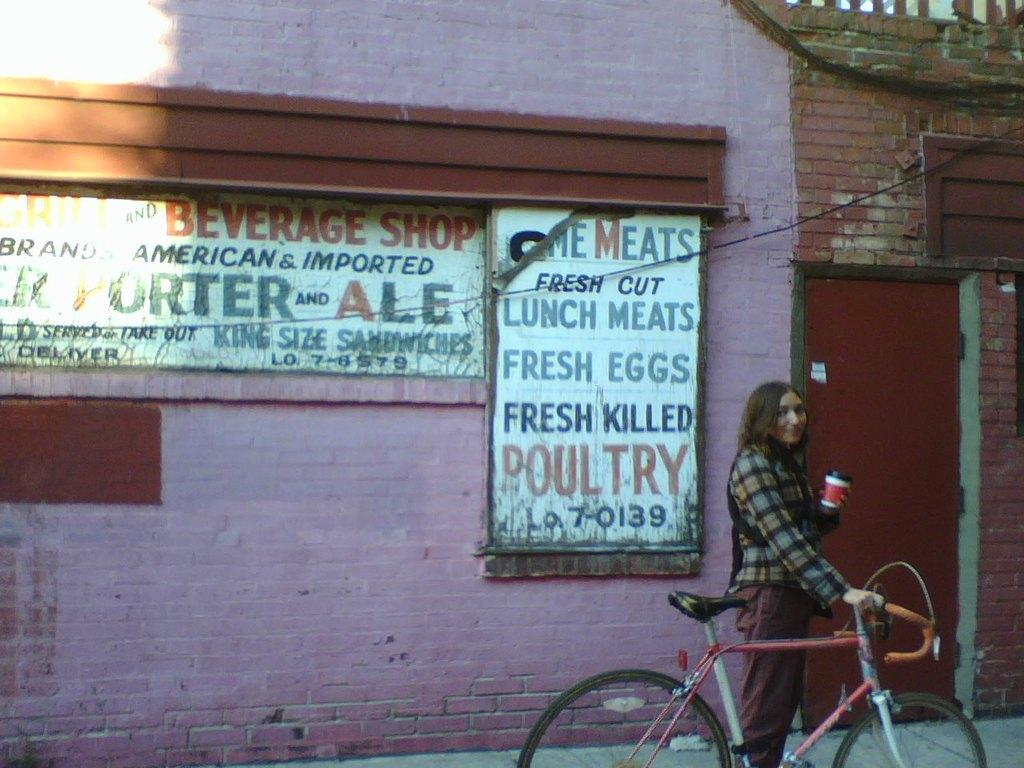What is the person in the image doing? The person is standing in the image and holding a bicycle. What else is the person holding in the image? The person is also holding a cup. What can be seen in the background of the image? There is a building in the background of the image. What features of the building are visible? The building has a door and boards. How does the person control the tray in the image? There is no tray present in the image, so the person cannot control a tray. 